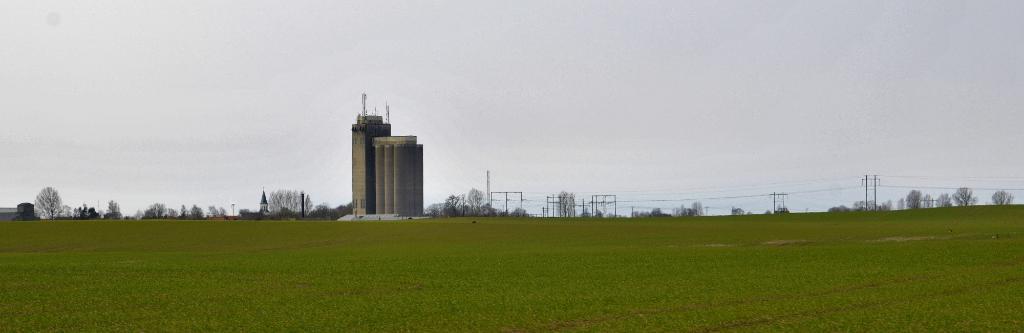In one or two sentences, can you explain what this image depicts? In this image I can see grass and trees in green color. Background I can see a building in gray and white color, few electric poles and the sky is in white color. 